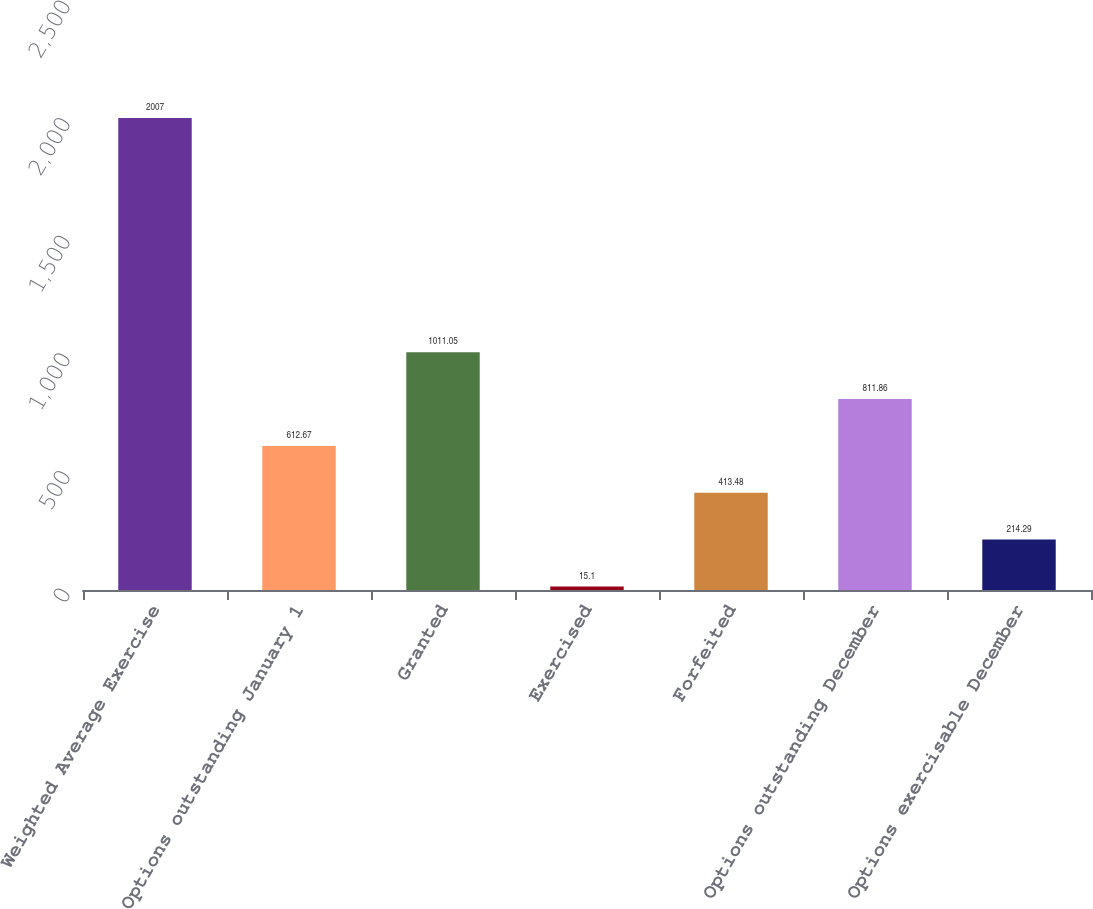Convert chart. <chart><loc_0><loc_0><loc_500><loc_500><bar_chart><fcel>Weighted Average Exercise<fcel>Options outstanding January 1<fcel>Granted<fcel>Exercised<fcel>Forfeited<fcel>Options outstanding December<fcel>Options exercisable December<nl><fcel>2007<fcel>612.67<fcel>1011.05<fcel>15.1<fcel>413.48<fcel>811.86<fcel>214.29<nl></chart> 